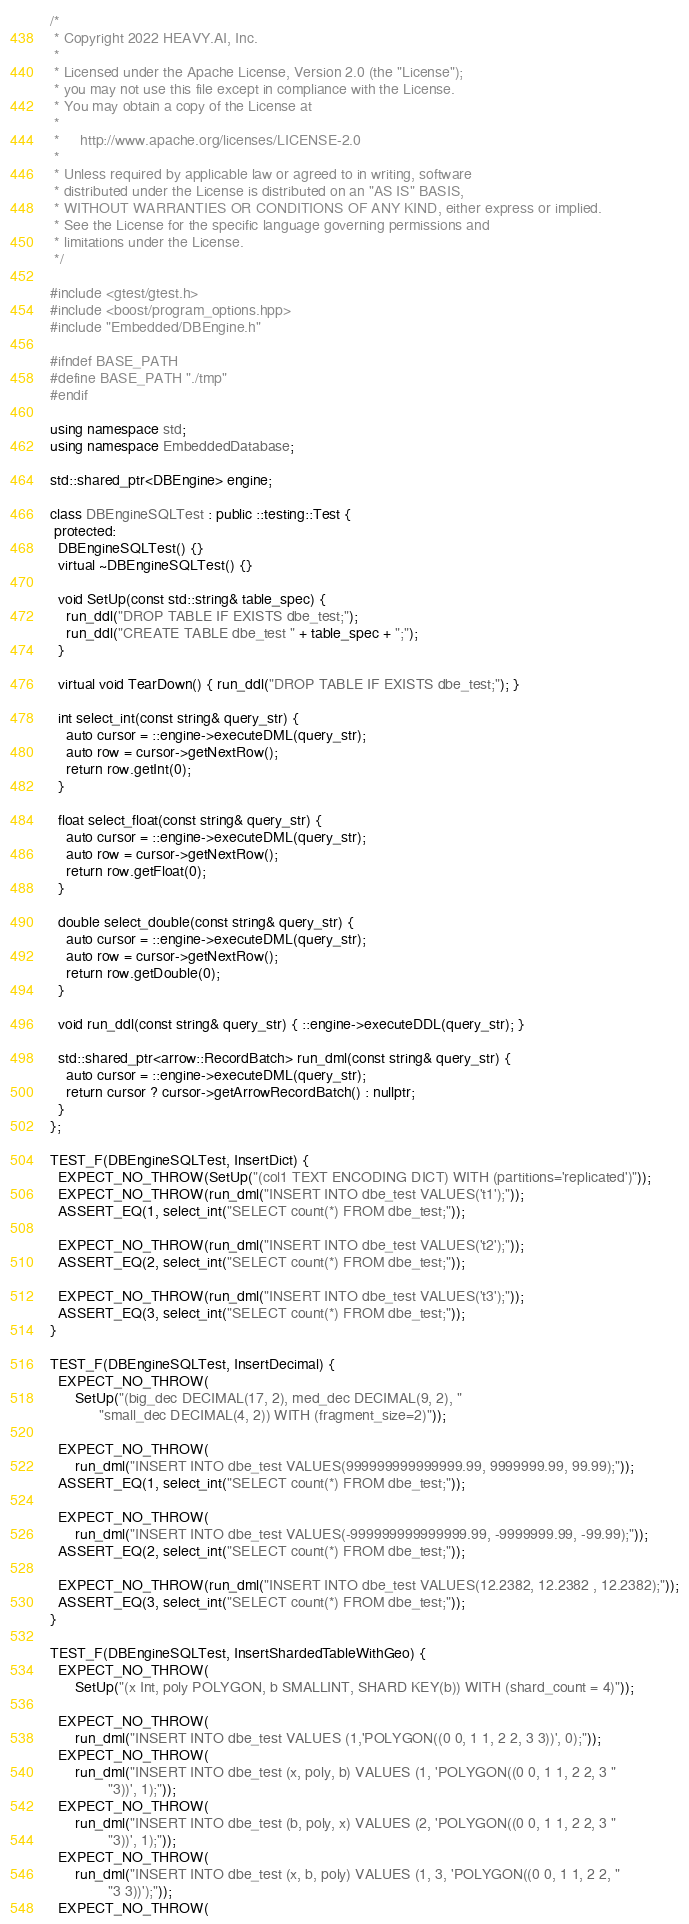<code> <loc_0><loc_0><loc_500><loc_500><_C++_>/*
 * Copyright 2022 HEAVY.AI, Inc.
 *
 * Licensed under the Apache License, Version 2.0 (the "License");
 * you may not use this file except in compliance with the License.
 * You may obtain a copy of the License at
 *
 *     http://www.apache.org/licenses/LICENSE-2.0
 *
 * Unless required by applicable law or agreed to in writing, software
 * distributed under the License is distributed on an "AS IS" BASIS,
 * WITHOUT WARRANTIES OR CONDITIONS OF ANY KIND, either express or implied.
 * See the License for the specific language governing permissions and
 * limitations under the License.
 */

#include <gtest/gtest.h>
#include <boost/program_options.hpp>
#include "Embedded/DBEngine.h"

#ifndef BASE_PATH
#define BASE_PATH "./tmp"
#endif

using namespace std;
using namespace EmbeddedDatabase;

std::shared_ptr<DBEngine> engine;

class DBEngineSQLTest : public ::testing::Test {
 protected:
  DBEngineSQLTest() {}
  virtual ~DBEngineSQLTest() {}

  void SetUp(const std::string& table_spec) {
    run_ddl("DROP TABLE IF EXISTS dbe_test;");
    run_ddl("CREATE TABLE dbe_test " + table_spec + ";");
  }

  virtual void TearDown() { run_ddl("DROP TABLE IF EXISTS dbe_test;"); }

  int select_int(const string& query_str) {
    auto cursor = ::engine->executeDML(query_str);
    auto row = cursor->getNextRow();
    return row.getInt(0);
  }

  float select_float(const string& query_str) {
    auto cursor = ::engine->executeDML(query_str);
    auto row = cursor->getNextRow();
    return row.getFloat(0);
  }

  double select_double(const string& query_str) {
    auto cursor = ::engine->executeDML(query_str);
    auto row = cursor->getNextRow();
    return row.getDouble(0);
  }

  void run_ddl(const string& query_str) { ::engine->executeDDL(query_str); }

  std::shared_ptr<arrow::RecordBatch> run_dml(const string& query_str) {
    auto cursor = ::engine->executeDML(query_str);
    return cursor ? cursor->getArrowRecordBatch() : nullptr;
  }
};

TEST_F(DBEngineSQLTest, InsertDict) {
  EXPECT_NO_THROW(SetUp("(col1 TEXT ENCODING DICT) WITH (partitions='replicated')"));
  EXPECT_NO_THROW(run_dml("INSERT INTO dbe_test VALUES('t1');"));
  ASSERT_EQ(1, select_int("SELECT count(*) FROM dbe_test;"));

  EXPECT_NO_THROW(run_dml("INSERT INTO dbe_test VALUES('t2');"));
  ASSERT_EQ(2, select_int("SELECT count(*) FROM dbe_test;"));

  EXPECT_NO_THROW(run_dml("INSERT INTO dbe_test VALUES('t3');"));
  ASSERT_EQ(3, select_int("SELECT count(*) FROM dbe_test;"));
}

TEST_F(DBEngineSQLTest, InsertDecimal) {
  EXPECT_NO_THROW(
      SetUp("(big_dec DECIMAL(17, 2), med_dec DECIMAL(9, 2), "
            "small_dec DECIMAL(4, 2)) WITH (fragment_size=2)"));

  EXPECT_NO_THROW(
      run_dml("INSERT INTO dbe_test VALUES(999999999999999.99, 9999999.99, 99.99);"));
  ASSERT_EQ(1, select_int("SELECT count(*) FROM dbe_test;"));

  EXPECT_NO_THROW(
      run_dml("INSERT INTO dbe_test VALUES(-999999999999999.99, -9999999.99, -99.99);"));
  ASSERT_EQ(2, select_int("SELECT count(*) FROM dbe_test;"));

  EXPECT_NO_THROW(run_dml("INSERT INTO dbe_test VALUES(12.2382, 12.2382 , 12.2382);"));
  ASSERT_EQ(3, select_int("SELECT count(*) FROM dbe_test;"));
}

TEST_F(DBEngineSQLTest, InsertShardedTableWithGeo) {
  EXPECT_NO_THROW(
      SetUp("(x Int, poly POLYGON, b SMALLINT, SHARD KEY(b)) WITH (shard_count = 4)"));

  EXPECT_NO_THROW(
      run_dml("INSERT INTO dbe_test VALUES (1,'POLYGON((0 0, 1 1, 2 2, 3 3))', 0);"));
  EXPECT_NO_THROW(
      run_dml("INSERT INTO dbe_test (x, poly, b) VALUES (1, 'POLYGON((0 0, 1 1, 2 2, 3 "
              "3))', 1);"));
  EXPECT_NO_THROW(
      run_dml("INSERT INTO dbe_test (b, poly, x) VALUES (2, 'POLYGON((0 0, 1 1, 2 2, 3 "
              "3))', 1);"));
  EXPECT_NO_THROW(
      run_dml("INSERT INTO dbe_test (x, b, poly) VALUES (1, 3, 'POLYGON((0 0, 1 1, 2 2, "
              "3 3))');"));
  EXPECT_NO_THROW(</code> 